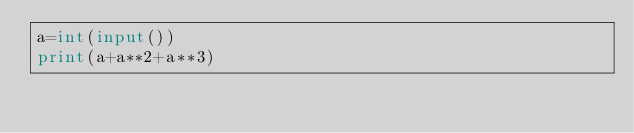<code> <loc_0><loc_0><loc_500><loc_500><_Python_>a=int(input())
print(a+a**2+a**3)</code> 